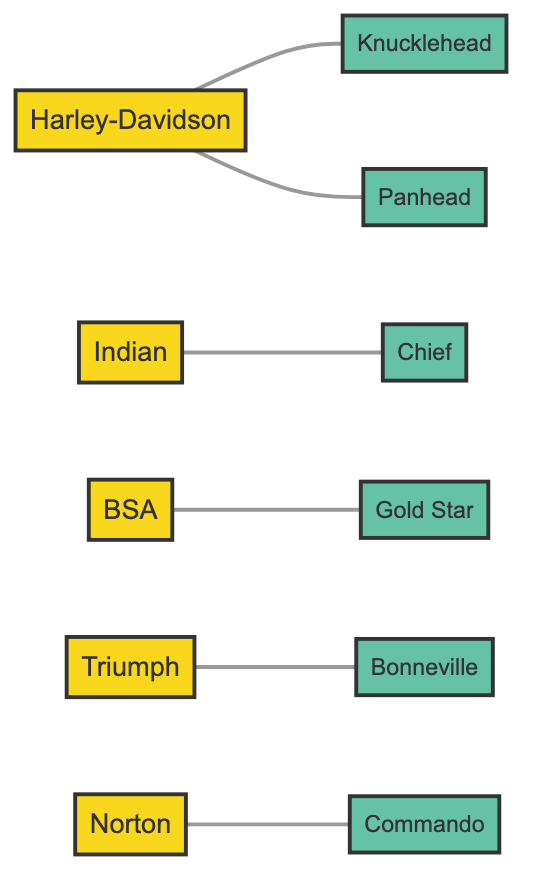What is the total number of nodes in the diagram? The nodes in the diagram represent manufacturers and motorcycle models. By counting the number of distinct nodes listed in the data, there are 11 nodes.
Answer: 11 Which manufacturer is connected to the Knucklehead model? The Knucklehead model, represented by node 6, is connected to the manufacturer Harley-Davidson, represented by node 1.
Answer: Harley-Davidson How many edges are present in the diagram? The edges in the diagram represent the relationships between manufacturers and their models. By counting the edges listed in the data, there are 6 edges.
Answer: 6 Which model corresponds to the Triumph manufacturer? The Triumph manufacturer, represented by node 4, is connected to the Bonneville model, represented by node 9, one of the connected models.
Answer: Bonneville How many manufacturers are connected to motorcycle models in the diagram? By examining the data, we see that all listed manufacturers (Harley-Davidson, Indian, BSA, Triumph, Norton) are connected to at least one motorcycle model. Thus, there are 5 manufacturers connected to models in the diagram.
Answer: 5 Which manufacturer has the most direct connections to its models? Each manufacturer has a varied number of connections; however, both Harley-Davidson (with connections to Knucklehead and Panhead) and Indian (with connection to Chief) have multiple models connected. Upon commenting on Harley-Davidson's models, it has more direct connections, totaling 2.
Answer: Harley-Davidson What type of graph is represented by the relationships between manufacturers and motorcycle models? This graph illustrates an undirected relationship as it shows connections without a defined directional flow between manufacturers and models; relationships can be traversed both ways.
Answer: Undirected Which motorcycle model is associated with the BSA manufacturer? The BSA manufacturer, represented by node 3, is associated with the Gold Star model, represented by node 8, as they share a direct connection in the diagram.
Answer: Gold Star 